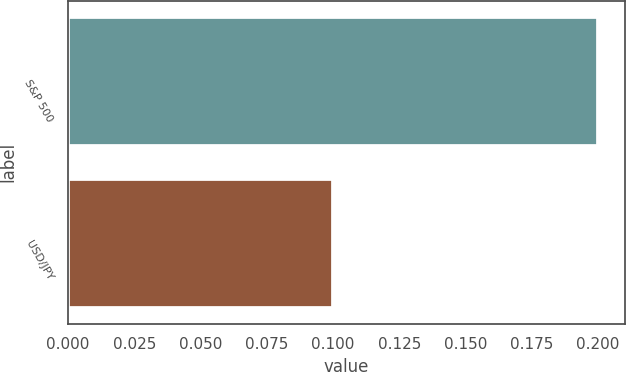Convert chart. <chart><loc_0><loc_0><loc_500><loc_500><bar_chart><fcel>S&P 500<fcel>USD/JPY<nl><fcel>0.2<fcel>0.1<nl></chart> 